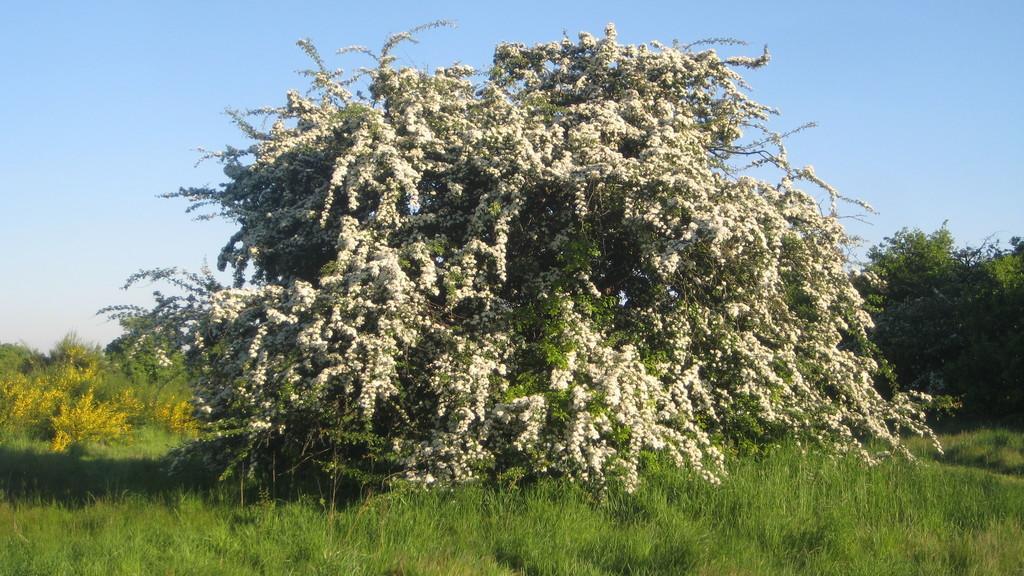In one or two sentences, can you explain what this image depicts? Here in this picture we can see plants present on the ground, which is fully covered with grass over there. 